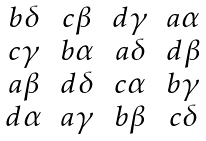Convert formula to latex. <formula><loc_0><loc_0><loc_500><loc_500>\begin{matrix} b \delta & c \beta & d \gamma & a \alpha \\ c \gamma & b \alpha & a \delta & d \beta \\ a \beta & d \delta & c \alpha & b \gamma \\ d \alpha & a \gamma & b \beta & c \delta \end{matrix}</formula> 